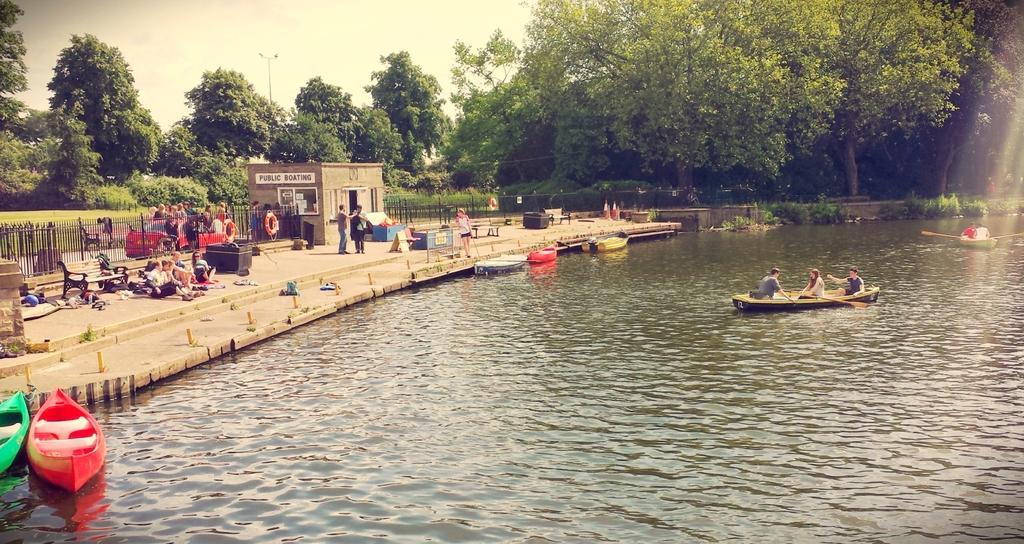Can you describe this image briefly? On the left side of the image we can see a house, board, windows, door, grilles, car, bench, divider cone, clothes, tubes and some people are standing and some of them are sitting on the floor. In the background of the image we can see the water, boats, some people are sitting on the boats and some of them are holding the sticks and also we can see the trees, grass, pole, lights. At the top of the image we can see the sky. 